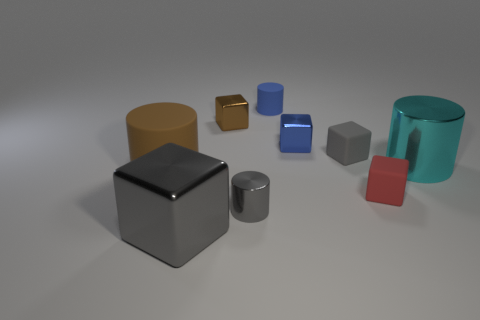The cube that is the same color as the large rubber cylinder is what size?
Your answer should be very brief. Small. There is a gray metallic object that is the same shape as the brown metallic thing; what size is it?
Provide a short and direct response. Large. There is a big matte object; is it the same color as the cube that is behind the blue metal block?
Provide a short and direct response. Yes. Is the large metallic cylinder the same color as the big metallic block?
Ensure brevity in your answer.  No. Is the number of small brown metal things less than the number of small shiny blocks?
Give a very brief answer. Yes. What number of other things are there of the same color as the big matte thing?
Ensure brevity in your answer.  1. How many cyan things are there?
Ensure brevity in your answer.  1. Is the number of small brown metallic cubes that are in front of the big cyan shiny object less than the number of green objects?
Provide a succinct answer. No. Is the tiny block that is in front of the cyan metal cylinder made of the same material as the large brown object?
Your response must be concise. Yes. There is a small shiny thing in front of the large metallic thing behind the small red matte object right of the large shiny cube; what shape is it?
Offer a very short reply. Cylinder. 